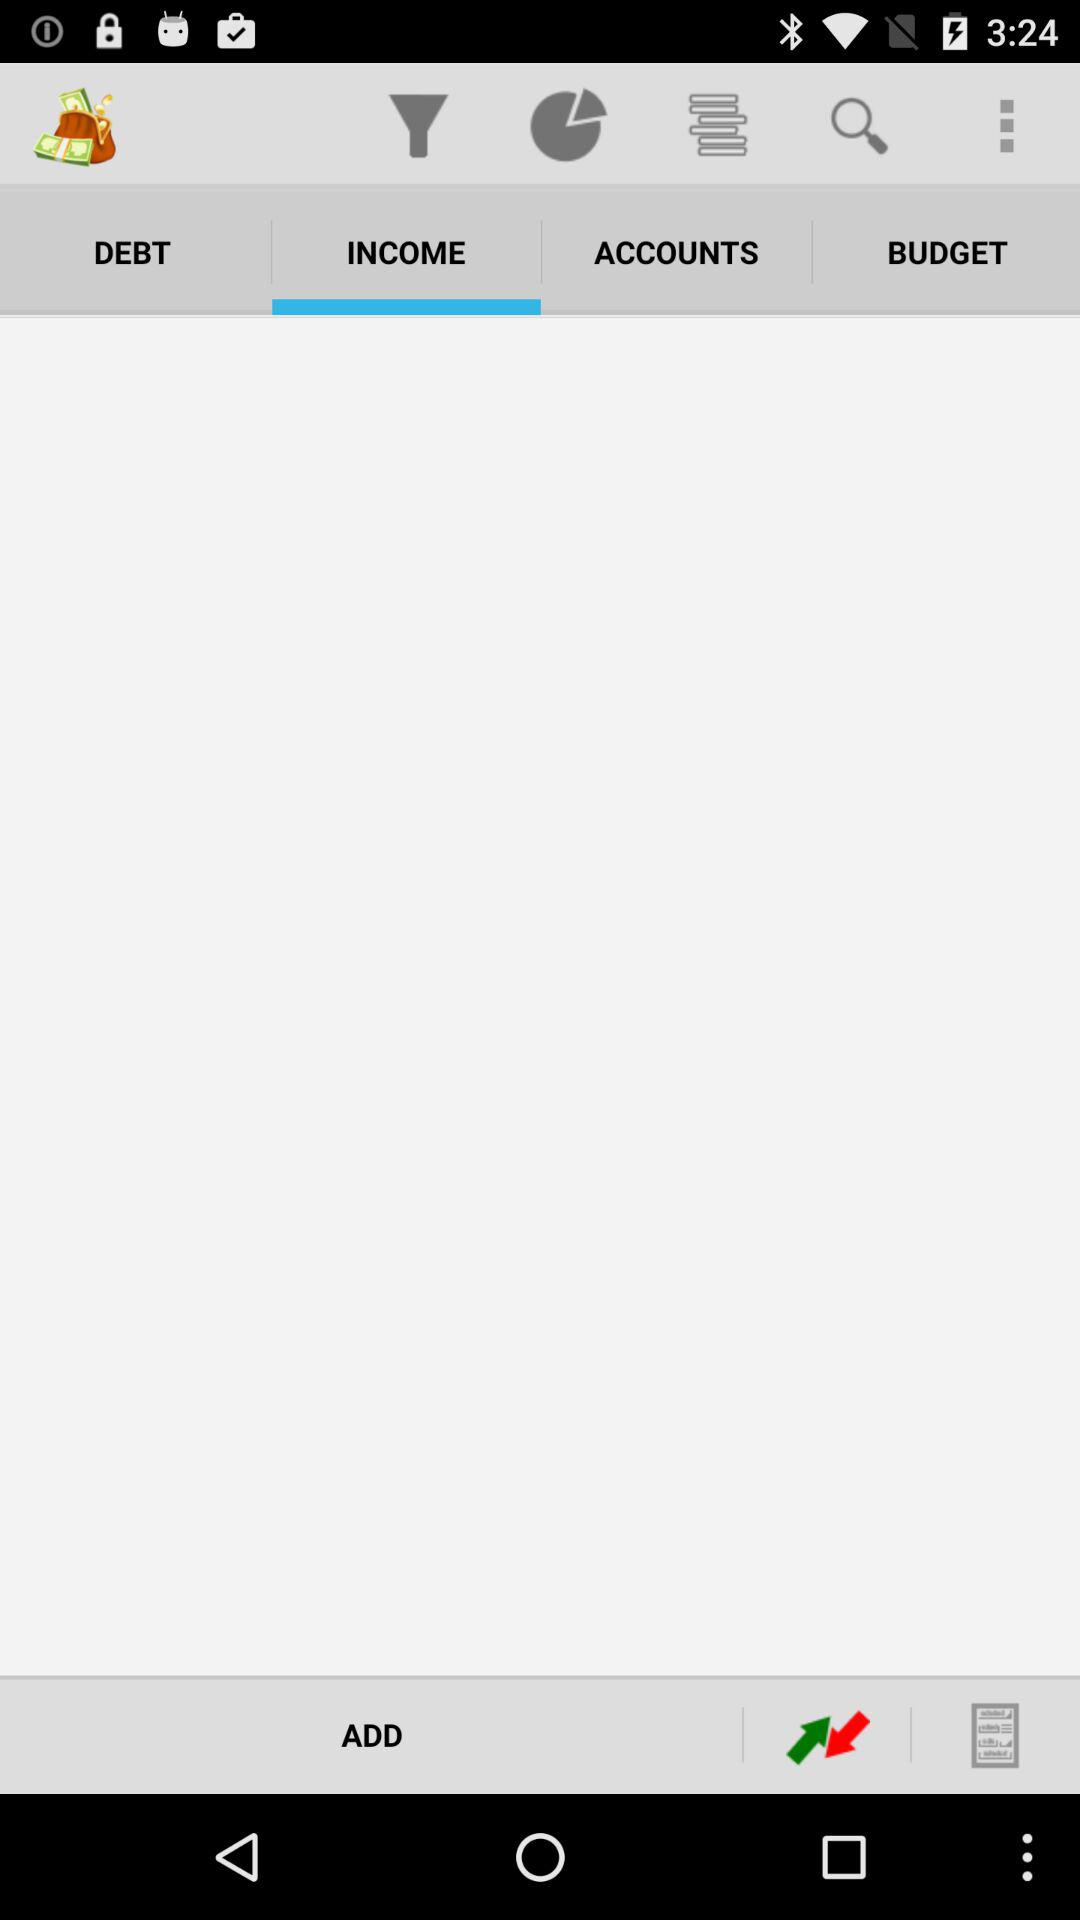How many notifications are there in "DEBT"?
When the provided information is insufficient, respond with <no answer>. <no answer> 